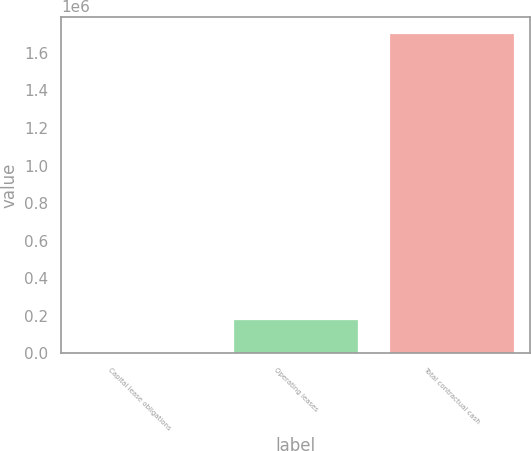Convert chart to OTSL. <chart><loc_0><loc_0><loc_500><loc_500><bar_chart><fcel>Capital lease obligations<fcel>Operating leases<fcel>Total contractual cash<nl><fcel>690<fcel>181800<fcel>1.70803e+06<nl></chart> 